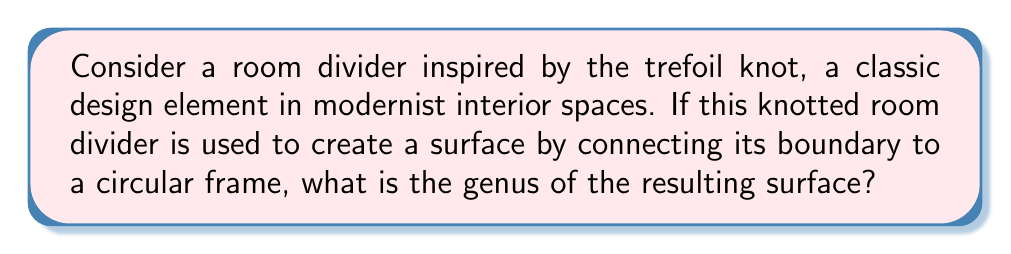Solve this math problem. To determine the genus of the surface created by the knotted room divider, we'll follow these steps:

1. Identify the knot: The trefoil knot is used in this design.

2. Calculate the crossing number: The trefoil knot has a crossing number of 3.

3. Use the formula for the genus of a knot:
   $$g = \frac{1}{2}(c - n + 1)$$
   where $g$ is the genus, $c$ is the crossing number, and $n$ is the number of components (which is 1 for a knot).

4. Substitute the values:
   $$g = \frac{1}{2}(3 - 1 + 1) = \frac{1}{2}(3) = \frac{3}{2}$$

5. The genus must be an integer, so we round up to the nearest whole number.

6. The surface created by connecting the boundary of the trefoil knot to a circular frame is equivalent to the surface obtained by taking the complement of the knot in $S^3$ and adding a disk (the circular frame). This operation doesn't change the genus.

Therefore, the genus of the surface created by the knotted room divider is 2.
Answer: 2 